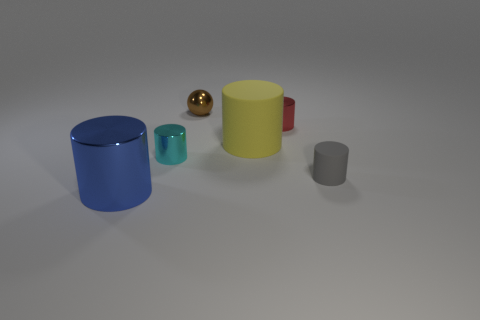Are these objects arranged in a specific way for a reason? The objects seem to be arranged deliberately with varying sizes and colors, possibly to convey a concept or to showcase a comparison among differently-sized cylindrical objects and a sphere, which can be seen as a study in geometry and color contrast. 